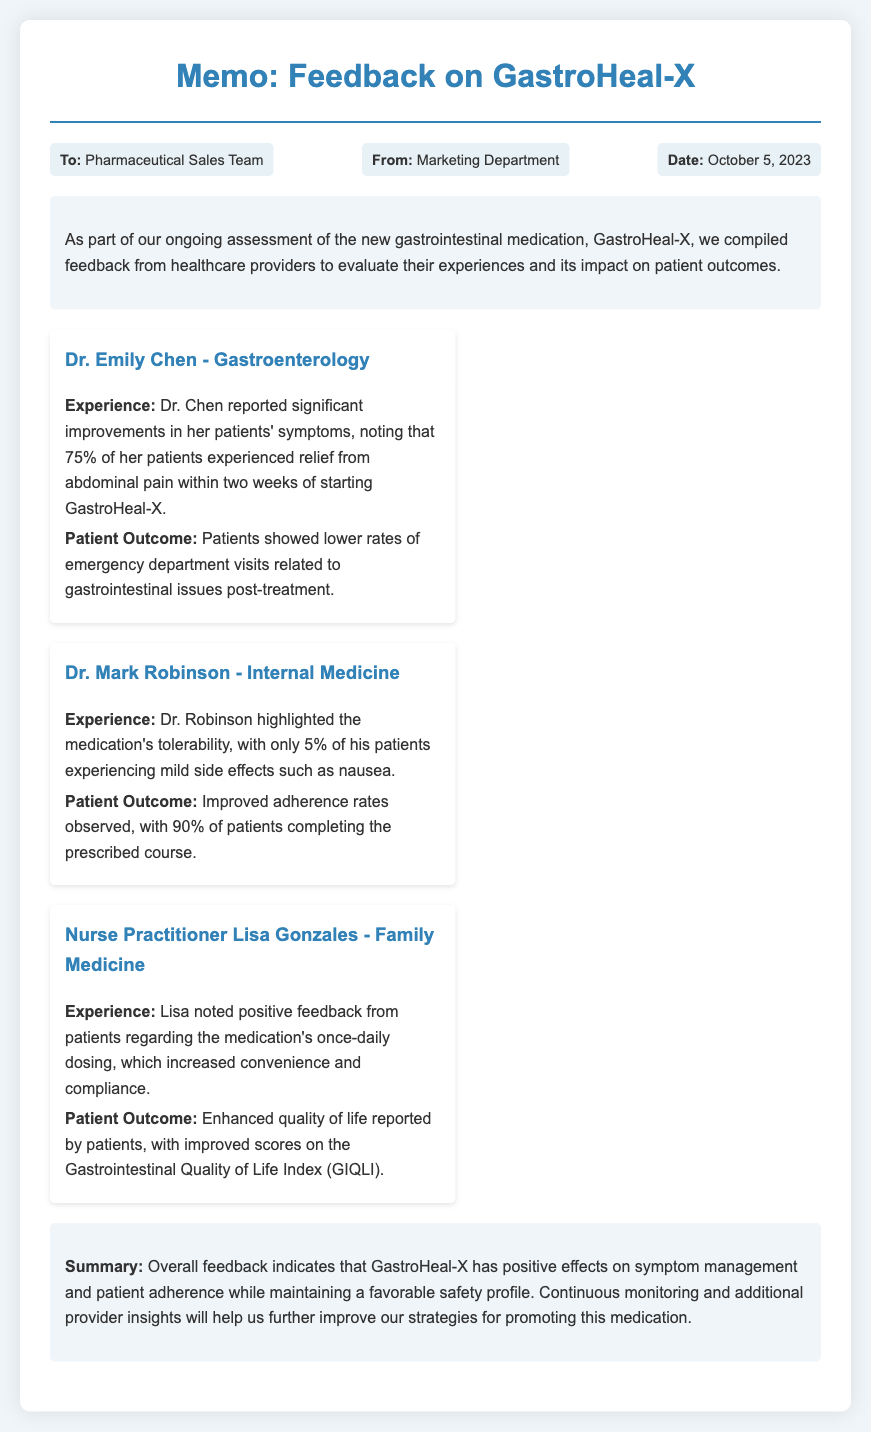What is the title of the memo? The title of the memo is mentioned at the beginning of the document.
Answer: Feedback on GastroHeal-X Who reported significant improvements in her patients' symptoms? The memo lists the healthcare provider's name associated with this feedback.
Answer: Dr. Emily Chen What percentage of Dr. Robinson's patients experienced mild side effects? This percentage is provided in the feedback from Dr. Robinson.
Answer: 5% What is the reported percentage of patients who experienced abdominal pain relief? This information is specified in Dr. Chen's feedback regarding treatment outcomes.
Answer: 75% What major benefit was noted by Nurse Practitioner Lisa Gonzales? This benefit is highlighted in her feedback regarding patient convenience.
Answer: Once-daily dosing What index showed improved scores according to Nurse Practitioner Gonzales? The memo specifies the name of the index related to quality of life improvements.
Answer: Gastrointestinal Quality of Life Index (GIQLI) What is the overall summary statement provided in the memo? The summary consolidates insights about the medication's effects and outcomes.
Answer: Positive effects on symptom management and patient adherence When was the memo dated? The date of the memo is explicitly stated in the meta information section.
Answer: October 5, 2023 